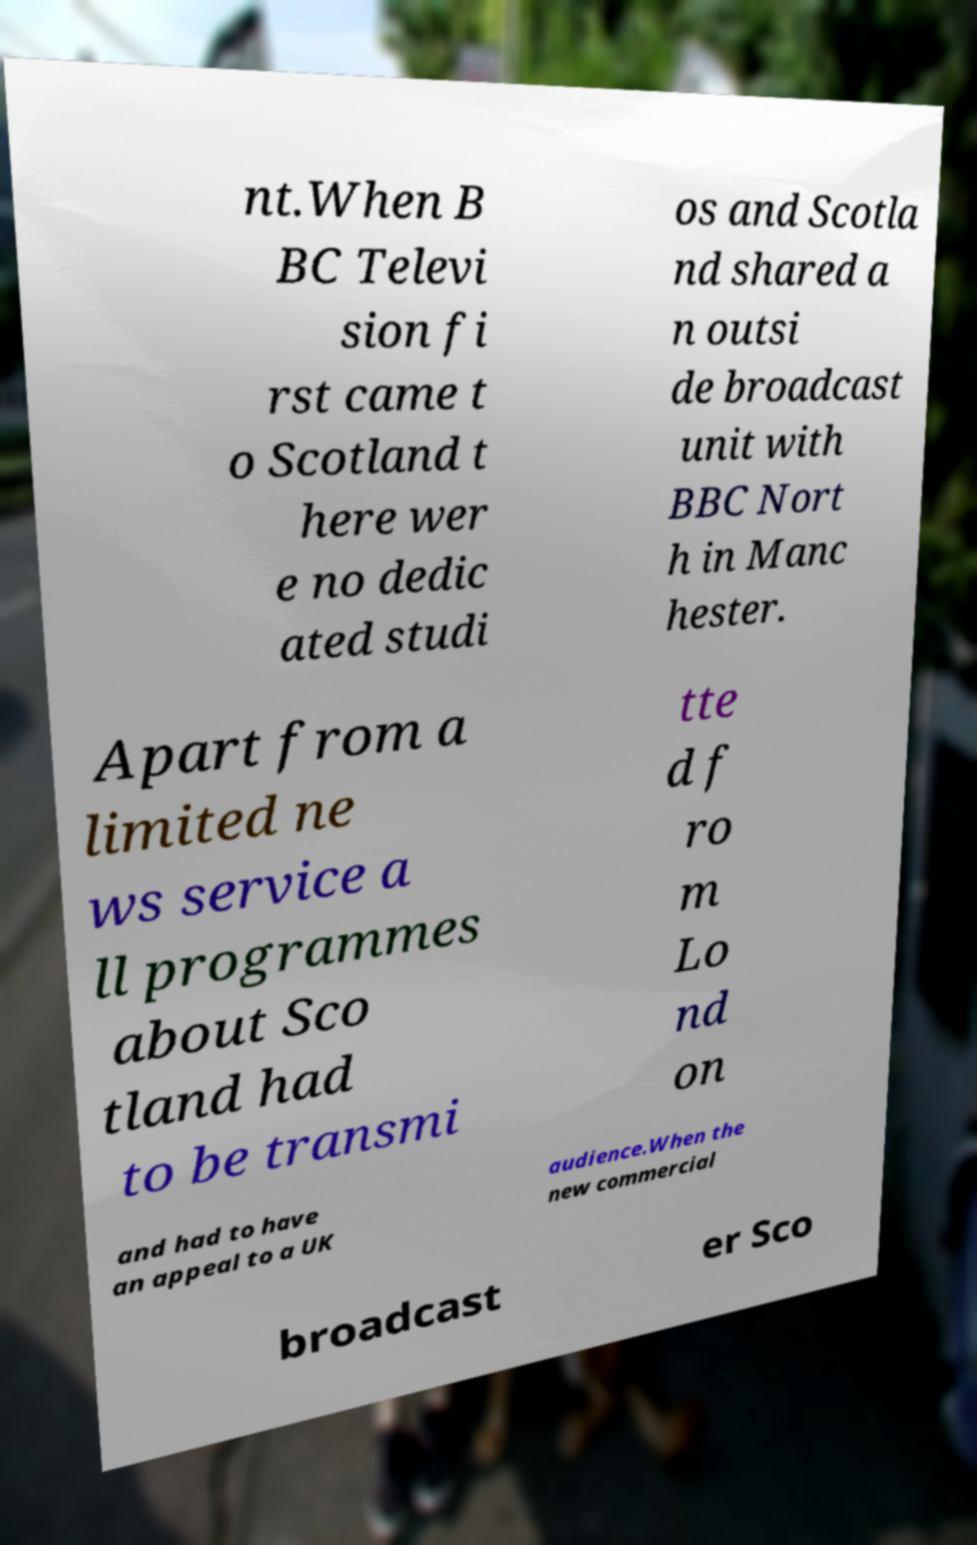What messages or text are displayed in this image? I need them in a readable, typed format. nt.When B BC Televi sion fi rst came t o Scotland t here wer e no dedic ated studi os and Scotla nd shared a n outsi de broadcast unit with BBC Nort h in Manc hester. Apart from a limited ne ws service a ll programmes about Sco tland had to be transmi tte d f ro m Lo nd on and had to have an appeal to a UK audience.When the new commercial broadcast er Sco 